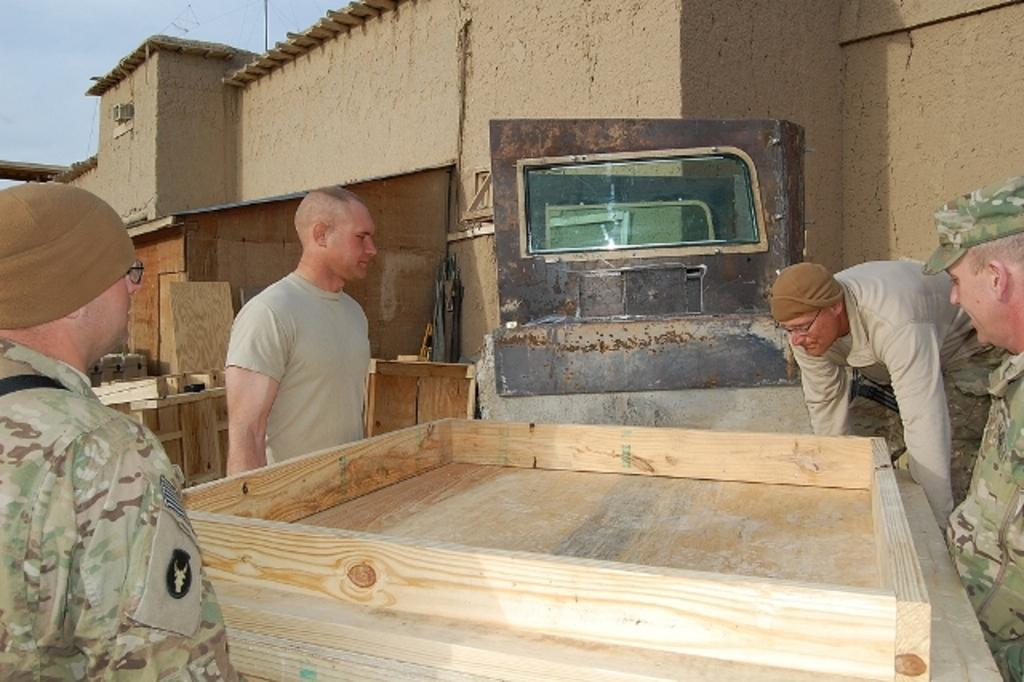What are the people in the image doing? The people in the image are standing and holding a table. What can be seen in the background of the image? There is a building in the background of the image. What part of the sky is visible in the image? The sky is visible in the top left corner of the image. How many ladybugs are crawling on the jeans of the person in the image? There are no ladybugs or jeans present in the image. What is the level of quietness in the image? The level of quietness cannot be determined from the image, as it only shows people holding a table and a building in the background. 